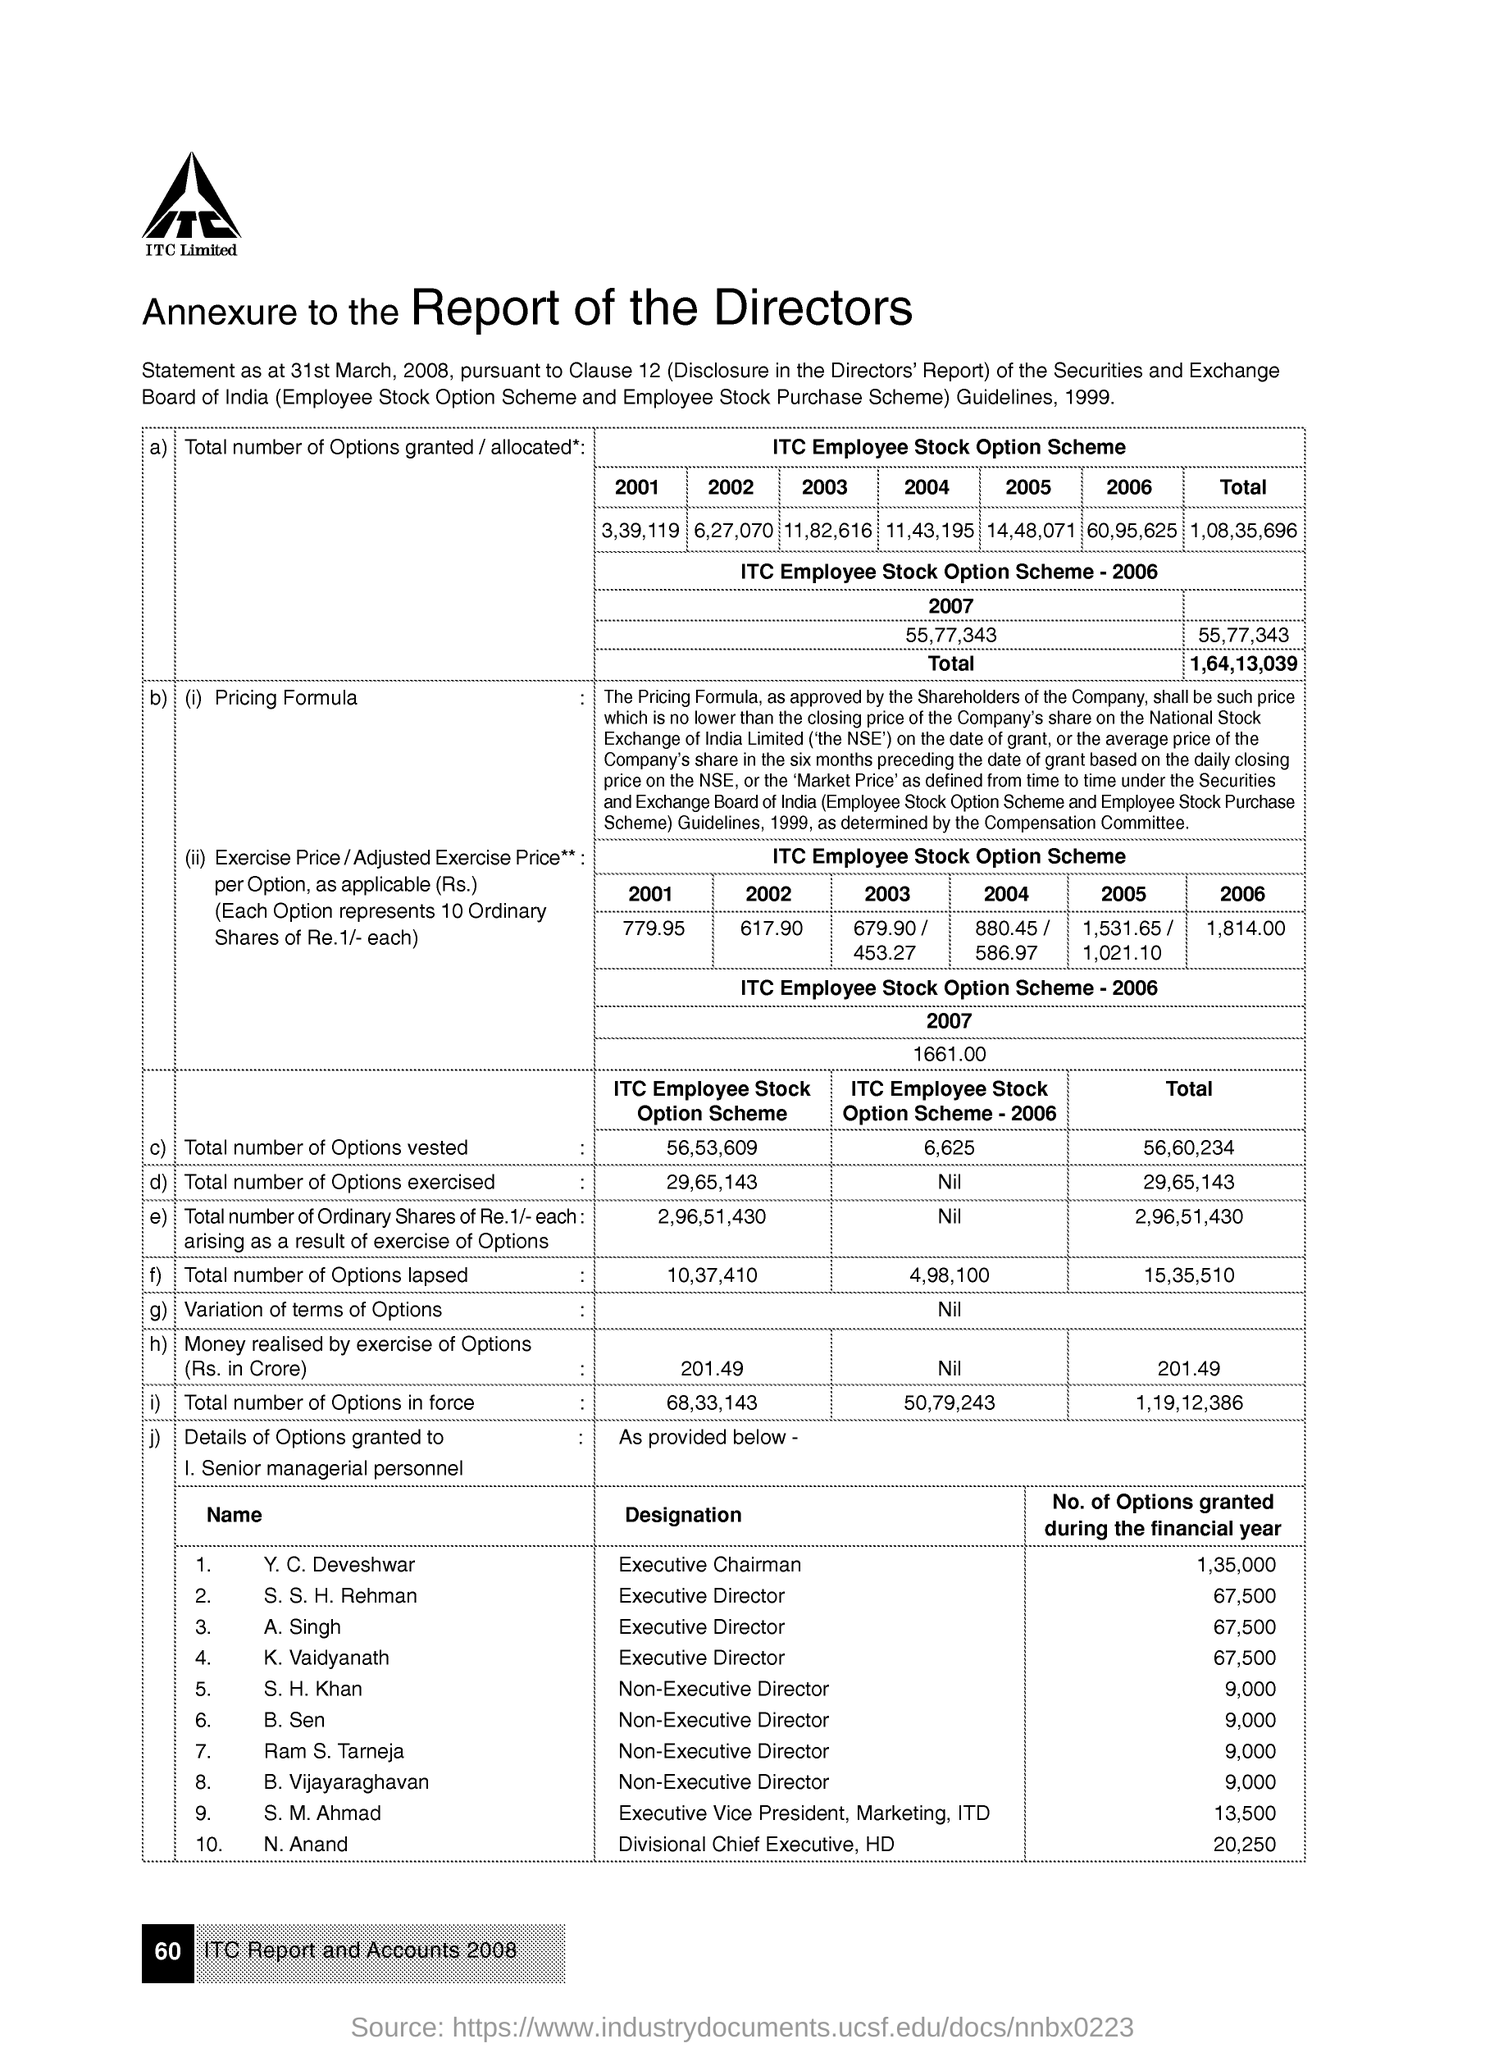What is the name of the company?
Give a very brief answer. ITC Limited. Who is executive chairman?
Ensure brevity in your answer.  Y.C. Deveshwar. How many number of options are granted to N Anand during the financial year?
Provide a short and direct response. 20,250. 